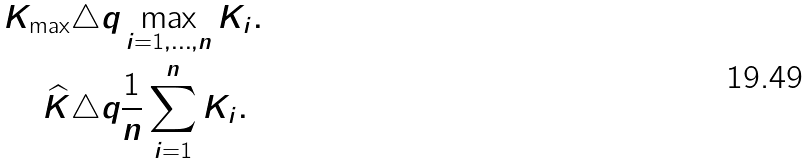Convert formula to latex. <formula><loc_0><loc_0><loc_500><loc_500>K _ { \max } & \triangle q \max _ { i = 1 , \dots , n } K _ { i } . \\ \widehat { K } & \triangle q \frac { 1 } { n } \sum _ { i = 1 } ^ { n } K _ { i } .</formula> 